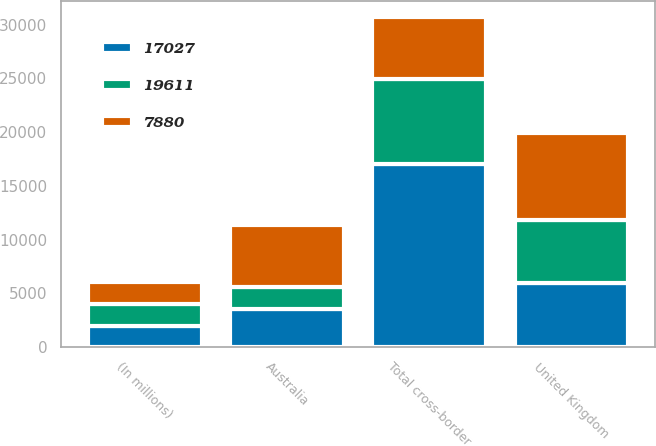Convert chart to OTSL. <chart><loc_0><loc_0><loc_500><loc_500><stacked_bar_chart><ecel><fcel>(In millions)<fcel>United Kingdom<fcel>Australia<fcel>Total cross-border<nl><fcel>7880<fcel>2009<fcel>8116<fcel>5767<fcel>5767<nl><fcel>19611<fcel>2008<fcel>5836<fcel>2044<fcel>7880<nl><fcel>17027<fcel>2007<fcel>5951<fcel>3567<fcel>17027<nl></chart> 